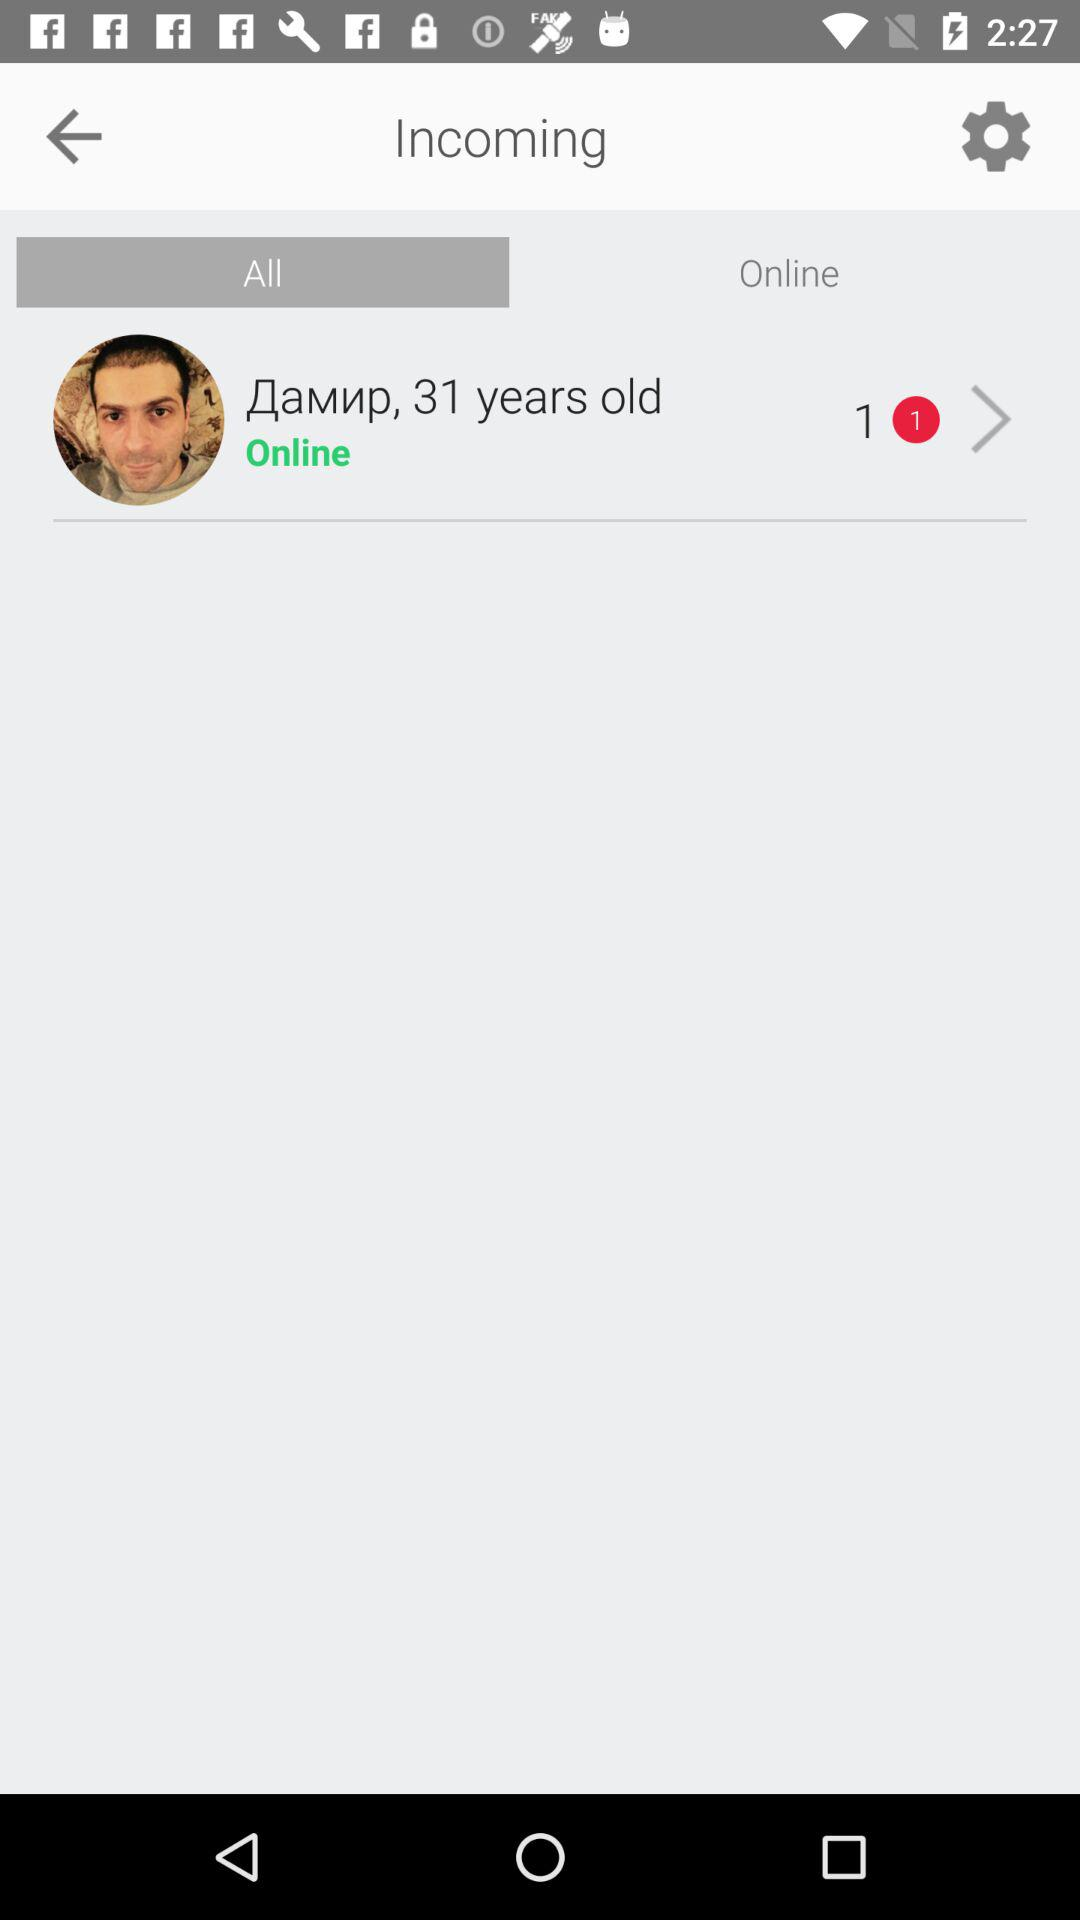What is the status of the person? The status is "Online". 